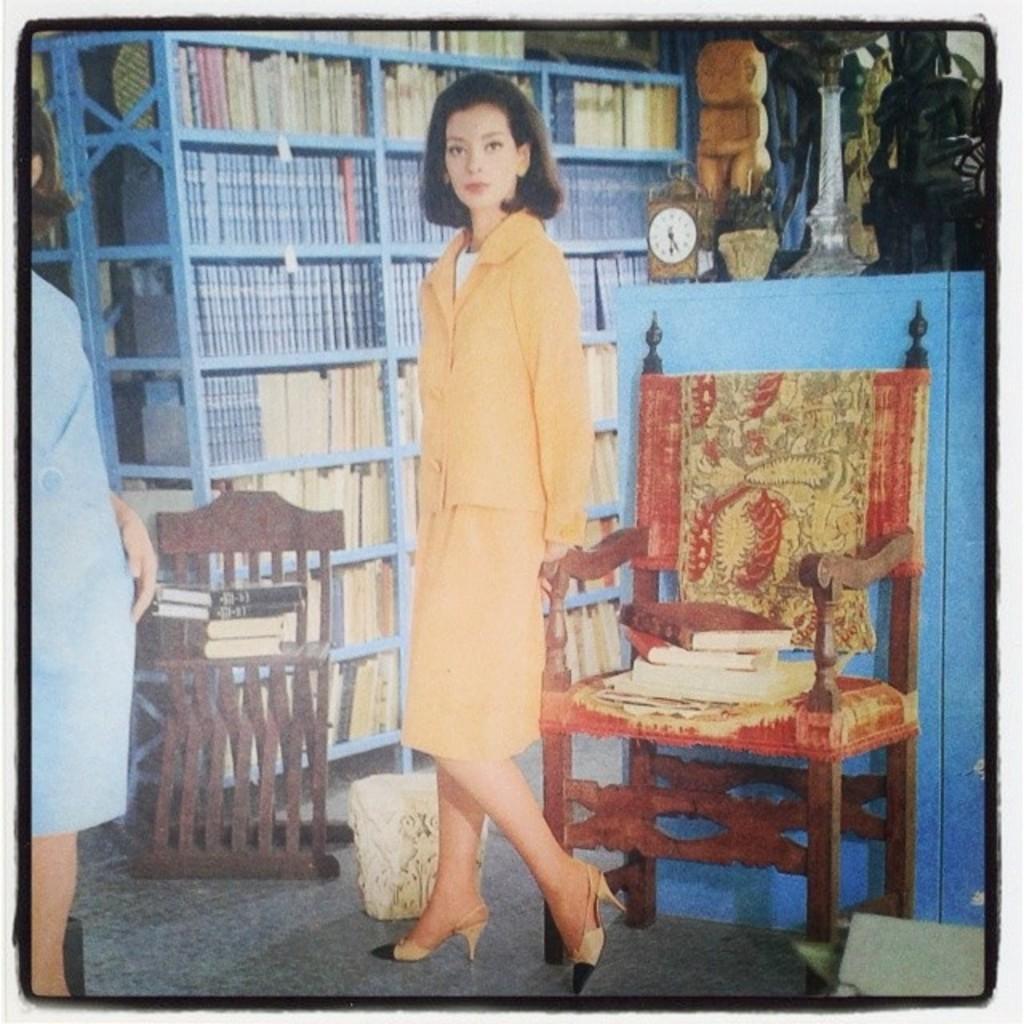How would you summarize this image in a sentence or two? In this image, I can see the woman standing. I can see the books, which are placed on the chairs. On the left side of the image, I can see another person standing. I can see few objects, which are placed on a table. These are the books, which are kept in the book shelves. 